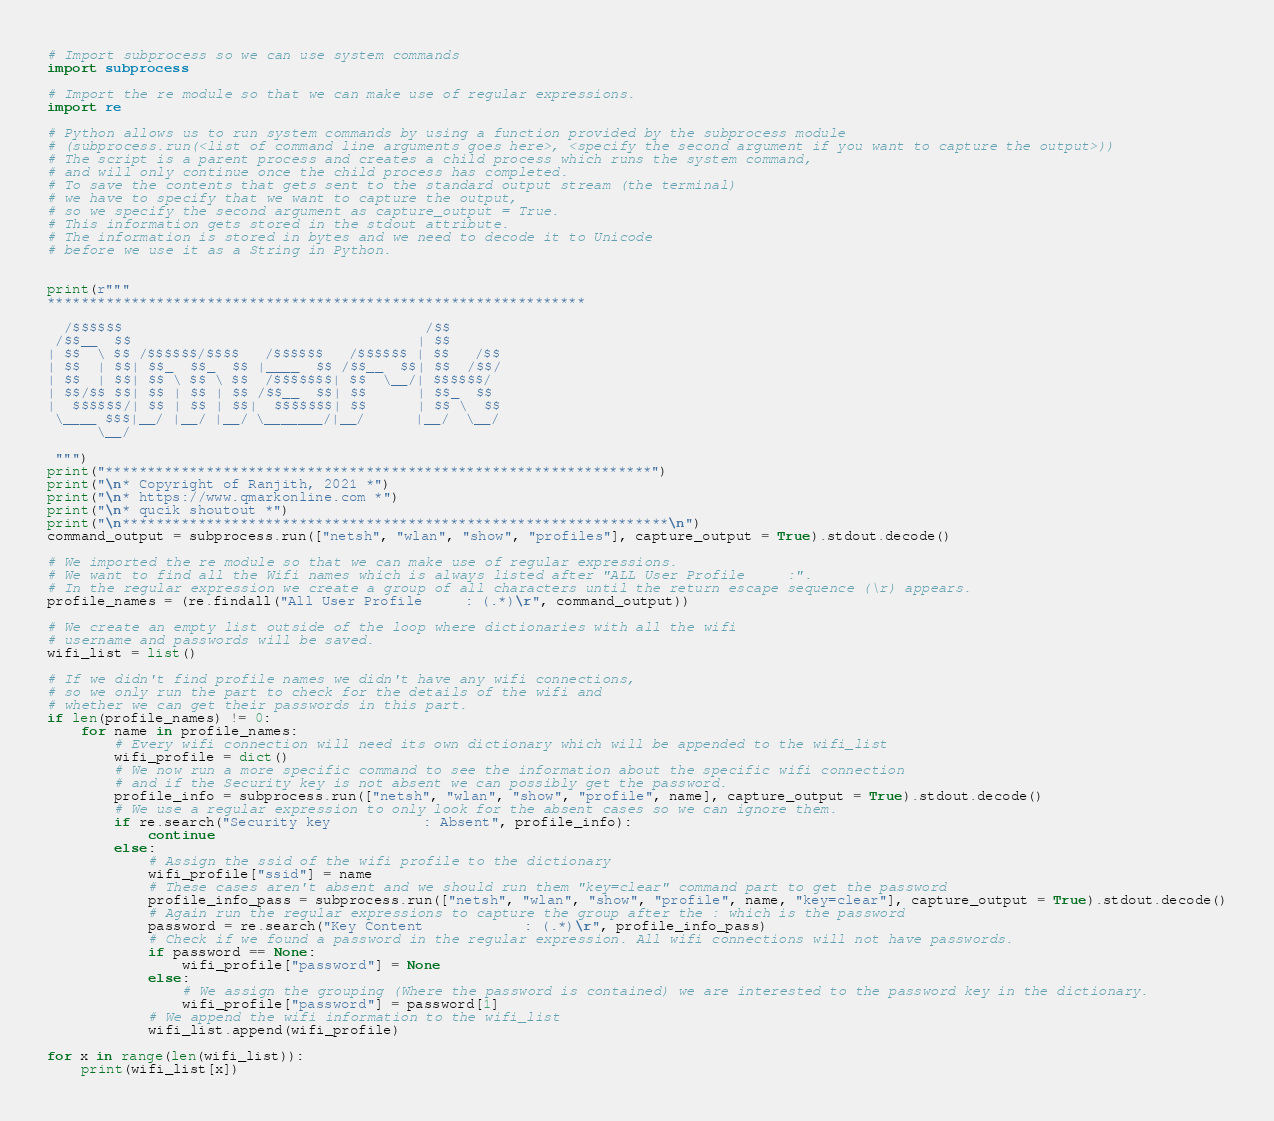<code> <loc_0><loc_0><loc_500><loc_500><_Python_>

# Import subprocess so we can use system commands
import subprocess

# Import the re module so that we can make use of regular expressions.
import re

# Python allows us to run system commands by using a function provided by the subprocess module
# (subprocess.run(<list of command line arguments goes here>, <specify the second argument if you want to capture the output>))
# The script is a parent process and creates a child process which runs the system command,
# and will only continue once the child process has completed.
# To save the contents that gets sent to the standard output stream (the terminal)
# we have to specify that we want to capture the output,
# so we specify the second argument as capture_output = True.
# This information gets stored in the stdout attribute.
# The information is stored in bytes and we need to decode it to Unicode
# before we use it as a String in Python.


print(r"""
****************************************************************

  /$$$$$$                                    /$$
 /$$__  $$                                  | $$
| $$  \ $$ /$$$$$$/$$$$   /$$$$$$   /$$$$$$ | $$   /$$
| $$  | $$| $$_  $$_  $$ |____  $$ /$$__  $$| $$  /$$/
| $$  | $$| $$ \ $$ \ $$  /$$$$$$$| $$  \__/| $$$$$$/
| $$/$$ $$| $$ | $$ | $$ /$$__  $$| $$      | $$_  $$
|  $$$$$$/| $$ | $$ | $$|  $$$$$$$| $$      | $$ \  $$
 \____ $$$|__/ |__/ |__/ \_______/|__/      |__/  \__/
      \__/

 """)
print("*****************************************************************")
print("\n* Copyright of Ranjith, 2021 *")
print("\n* https://www.qmarkonline.com *")
print("\n* qucik shoutout *")
print("\n*****************************************************************\n")
command_output = subprocess.run(["netsh", "wlan", "show", "profiles"], capture_output = True).stdout.decode()

# We imported the re module so that we can make use of regular expressions.
# We want to find all the Wifi names which is always listed after "ALL User Profile     :".
# In the regular expression we create a group of all characters until the return escape sequence (\r) appears.
profile_names = (re.findall("All User Profile     : (.*)\r", command_output))

# We create an empty list outside of the loop where dictionaries with all the wifi
# username and passwords will be saved.
wifi_list = list()

# If we didn't find profile names we didn't have any wifi connections,
# so we only run the part to check for the details of the wifi and
# whether we can get their passwords in this part.
if len(profile_names) != 0:
    for name in profile_names:
        # Every wifi connection will need its own dictionary which will be appended to the wifi_list
        wifi_profile = dict()
        # We now run a more specific command to see the information about the specific wifi connection
        # and if the Security key is not absent we can possibly get the password.
        profile_info = subprocess.run(["netsh", "wlan", "show", "profile", name], capture_output = True).stdout.decode()
        # We use a regular expression to only look for the absent cases so we can ignore them.
        if re.search("Security key           : Absent", profile_info):
            continue
        else:
            # Assign the ssid of the wifi profile to the dictionary
            wifi_profile["ssid"] = name
            # These cases aren't absent and we should run them "key=clear" command part to get the password
            profile_info_pass = subprocess.run(["netsh", "wlan", "show", "profile", name, "key=clear"], capture_output = True).stdout.decode()
            # Again run the regular expressions to capture the group after the : which is the password
            password = re.search("Key Content            : (.*)\r", profile_info_pass)
            # Check if we found a password in the regular expression. All wifi connections will not have passwords.
            if password == None:
                wifi_profile["password"] = None
            else:
                # We assign the grouping (Where the password is contained) we are interested to the password key in the dictionary.
                wifi_profile["password"] = password[1]
            # We append the wifi information to the wifi_list
            wifi_list.append(wifi_profile)

for x in range(len(wifi_list)):
    print(wifi_list[x])
</code> 